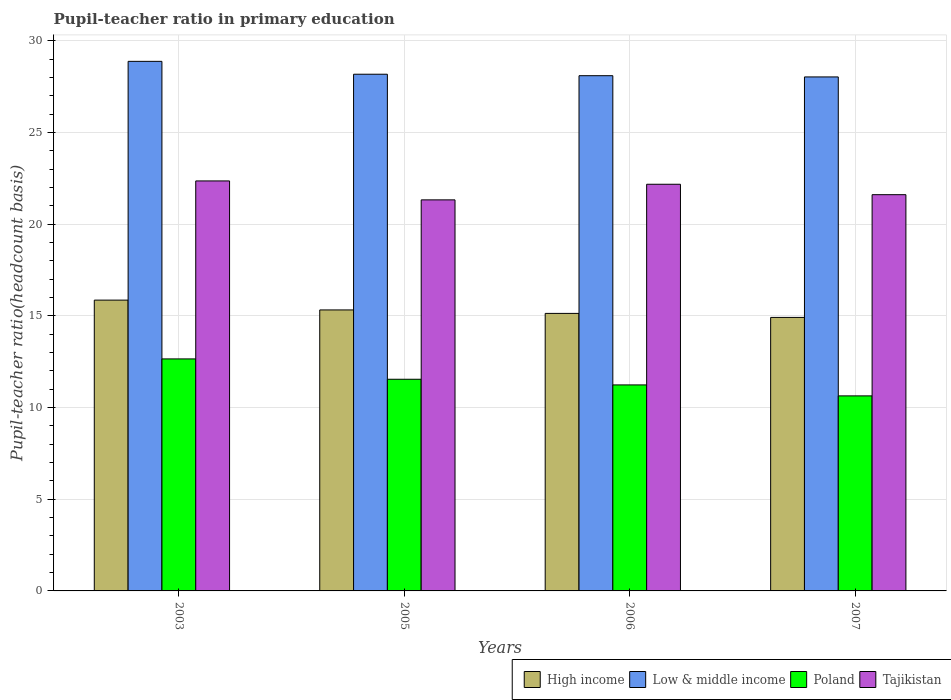Are the number of bars per tick equal to the number of legend labels?
Provide a short and direct response. Yes. How many bars are there on the 3rd tick from the right?
Offer a very short reply. 4. In how many cases, is the number of bars for a given year not equal to the number of legend labels?
Provide a short and direct response. 0. What is the pupil-teacher ratio in primary education in Poland in 2003?
Give a very brief answer. 12.65. Across all years, what is the maximum pupil-teacher ratio in primary education in High income?
Provide a succinct answer. 15.86. Across all years, what is the minimum pupil-teacher ratio in primary education in High income?
Provide a short and direct response. 14.92. In which year was the pupil-teacher ratio in primary education in Low & middle income maximum?
Your answer should be compact. 2003. What is the total pupil-teacher ratio in primary education in Tajikistan in the graph?
Make the answer very short. 87.47. What is the difference between the pupil-teacher ratio in primary education in Poland in 2003 and that in 2006?
Offer a terse response. 1.42. What is the difference between the pupil-teacher ratio in primary education in Low & middle income in 2003 and the pupil-teacher ratio in primary education in Poland in 2005?
Your answer should be very brief. 17.34. What is the average pupil-teacher ratio in primary education in Poland per year?
Your answer should be compact. 11.52. In the year 2007, what is the difference between the pupil-teacher ratio in primary education in High income and pupil-teacher ratio in primary education in Poland?
Your answer should be compact. 4.28. In how many years, is the pupil-teacher ratio in primary education in High income greater than 3?
Offer a terse response. 4. What is the ratio of the pupil-teacher ratio in primary education in Tajikistan in 2005 to that in 2007?
Give a very brief answer. 0.99. Is the pupil-teacher ratio in primary education in Low & middle income in 2003 less than that in 2005?
Provide a succinct answer. No. What is the difference between the highest and the second highest pupil-teacher ratio in primary education in Poland?
Provide a short and direct response. 1.11. What is the difference between the highest and the lowest pupil-teacher ratio in primary education in High income?
Offer a terse response. 0.94. Is the sum of the pupil-teacher ratio in primary education in Low & middle income in 2003 and 2005 greater than the maximum pupil-teacher ratio in primary education in High income across all years?
Offer a very short reply. Yes. What does the 2nd bar from the right in 2007 represents?
Give a very brief answer. Poland. Is it the case that in every year, the sum of the pupil-teacher ratio in primary education in Tajikistan and pupil-teacher ratio in primary education in Poland is greater than the pupil-teacher ratio in primary education in Low & middle income?
Your answer should be compact. Yes. How many bars are there?
Your answer should be compact. 16. How many years are there in the graph?
Give a very brief answer. 4. What is the difference between two consecutive major ticks on the Y-axis?
Provide a short and direct response. 5. Are the values on the major ticks of Y-axis written in scientific E-notation?
Offer a very short reply. No. Does the graph contain grids?
Your answer should be very brief. Yes. How many legend labels are there?
Keep it short and to the point. 4. How are the legend labels stacked?
Your answer should be very brief. Horizontal. What is the title of the graph?
Your answer should be compact. Pupil-teacher ratio in primary education. What is the label or title of the Y-axis?
Your response must be concise. Pupil-teacher ratio(headcount basis). What is the Pupil-teacher ratio(headcount basis) of High income in 2003?
Offer a very short reply. 15.86. What is the Pupil-teacher ratio(headcount basis) of Low & middle income in 2003?
Offer a very short reply. 28.88. What is the Pupil-teacher ratio(headcount basis) in Poland in 2003?
Provide a succinct answer. 12.65. What is the Pupil-teacher ratio(headcount basis) of Tajikistan in 2003?
Keep it short and to the point. 22.36. What is the Pupil-teacher ratio(headcount basis) in High income in 2005?
Keep it short and to the point. 15.32. What is the Pupil-teacher ratio(headcount basis) of Low & middle income in 2005?
Give a very brief answer. 28.18. What is the Pupil-teacher ratio(headcount basis) in Poland in 2005?
Make the answer very short. 11.54. What is the Pupil-teacher ratio(headcount basis) in Tajikistan in 2005?
Make the answer very short. 21.33. What is the Pupil-teacher ratio(headcount basis) of High income in 2006?
Make the answer very short. 15.14. What is the Pupil-teacher ratio(headcount basis) of Low & middle income in 2006?
Offer a terse response. 28.1. What is the Pupil-teacher ratio(headcount basis) in Poland in 2006?
Make the answer very short. 11.23. What is the Pupil-teacher ratio(headcount basis) of Tajikistan in 2006?
Provide a short and direct response. 22.18. What is the Pupil-teacher ratio(headcount basis) of High income in 2007?
Make the answer very short. 14.92. What is the Pupil-teacher ratio(headcount basis) in Low & middle income in 2007?
Keep it short and to the point. 28.03. What is the Pupil-teacher ratio(headcount basis) of Poland in 2007?
Offer a terse response. 10.64. What is the Pupil-teacher ratio(headcount basis) of Tajikistan in 2007?
Ensure brevity in your answer.  21.61. Across all years, what is the maximum Pupil-teacher ratio(headcount basis) in High income?
Give a very brief answer. 15.86. Across all years, what is the maximum Pupil-teacher ratio(headcount basis) of Low & middle income?
Give a very brief answer. 28.88. Across all years, what is the maximum Pupil-teacher ratio(headcount basis) in Poland?
Your answer should be compact. 12.65. Across all years, what is the maximum Pupil-teacher ratio(headcount basis) in Tajikistan?
Provide a short and direct response. 22.36. Across all years, what is the minimum Pupil-teacher ratio(headcount basis) in High income?
Provide a succinct answer. 14.92. Across all years, what is the minimum Pupil-teacher ratio(headcount basis) of Low & middle income?
Your answer should be compact. 28.03. Across all years, what is the minimum Pupil-teacher ratio(headcount basis) of Poland?
Offer a very short reply. 10.64. Across all years, what is the minimum Pupil-teacher ratio(headcount basis) in Tajikistan?
Make the answer very short. 21.33. What is the total Pupil-teacher ratio(headcount basis) of High income in the graph?
Your response must be concise. 61.23. What is the total Pupil-teacher ratio(headcount basis) of Low & middle income in the graph?
Keep it short and to the point. 113.19. What is the total Pupil-teacher ratio(headcount basis) in Poland in the graph?
Your answer should be compact. 46.07. What is the total Pupil-teacher ratio(headcount basis) in Tajikistan in the graph?
Give a very brief answer. 87.47. What is the difference between the Pupil-teacher ratio(headcount basis) of High income in 2003 and that in 2005?
Offer a very short reply. 0.54. What is the difference between the Pupil-teacher ratio(headcount basis) of Low & middle income in 2003 and that in 2005?
Make the answer very short. 0.7. What is the difference between the Pupil-teacher ratio(headcount basis) in Poland in 2003 and that in 2005?
Keep it short and to the point. 1.11. What is the difference between the Pupil-teacher ratio(headcount basis) of Tajikistan in 2003 and that in 2005?
Make the answer very short. 1.03. What is the difference between the Pupil-teacher ratio(headcount basis) in High income in 2003 and that in 2006?
Your answer should be very brief. 0.72. What is the difference between the Pupil-teacher ratio(headcount basis) of Low & middle income in 2003 and that in 2006?
Offer a terse response. 0.78. What is the difference between the Pupil-teacher ratio(headcount basis) in Poland in 2003 and that in 2006?
Your response must be concise. 1.42. What is the difference between the Pupil-teacher ratio(headcount basis) of Tajikistan in 2003 and that in 2006?
Offer a terse response. 0.18. What is the difference between the Pupil-teacher ratio(headcount basis) in High income in 2003 and that in 2007?
Ensure brevity in your answer.  0.94. What is the difference between the Pupil-teacher ratio(headcount basis) in Low & middle income in 2003 and that in 2007?
Keep it short and to the point. 0.85. What is the difference between the Pupil-teacher ratio(headcount basis) of Poland in 2003 and that in 2007?
Your answer should be very brief. 2.02. What is the difference between the Pupil-teacher ratio(headcount basis) of Tajikistan in 2003 and that in 2007?
Your answer should be compact. 0.75. What is the difference between the Pupil-teacher ratio(headcount basis) in High income in 2005 and that in 2006?
Your answer should be compact. 0.19. What is the difference between the Pupil-teacher ratio(headcount basis) in Low & middle income in 2005 and that in 2006?
Your answer should be compact. 0.08. What is the difference between the Pupil-teacher ratio(headcount basis) of Poland in 2005 and that in 2006?
Your answer should be compact. 0.31. What is the difference between the Pupil-teacher ratio(headcount basis) in Tajikistan in 2005 and that in 2006?
Offer a terse response. -0.85. What is the difference between the Pupil-teacher ratio(headcount basis) of High income in 2005 and that in 2007?
Give a very brief answer. 0.41. What is the difference between the Pupil-teacher ratio(headcount basis) in Low & middle income in 2005 and that in 2007?
Offer a terse response. 0.15. What is the difference between the Pupil-teacher ratio(headcount basis) in Poland in 2005 and that in 2007?
Give a very brief answer. 0.91. What is the difference between the Pupil-teacher ratio(headcount basis) in Tajikistan in 2005 and that in 2007?
Your answer should be very brief. -0.28. What is the difference between the Pupil-teacher ratio(headcount basis) of High income in 2006 and that in 2007?
Your answer should be very brief. 0.22. What is the difference between the Pupil-teacher ratio(headcount basis) in Low & middle income in 2006 and that in 2007?
Your answer should be very brief. 0.07. What is the difference between the Pupil-teacher ratio(headcount basis) of Poland in 2006 and that in 2007?
Your response must be concise. 0.6. What is the difference between the Pupil-teacher ratio(headcount basis) in Tajikistan in 2006 and that in 2007?
Give a very brief answer. 0.57. What is the difference between the Pupil-teacher ratio(headcount basis) of High income in 2003 and the Pupil-teacher ratio(headcount basis) of Low & middle income in 2005?
Provide a short and direct response. -12.32. What is the difference between the Pupil-teacher ratio(headcount basis) of High income in 2003 and the Pupil-teacher ratio(headcount basis) of Poland in 2005?
Make the answer very short. 4.32. What is the difference between the Pupil-teacher ratio(headcount basis) in High income in 2003 and the Pupil-teacher ratio(headcount basis) in Tajikistan in 2005?
Make the answer very short. -5.47. What is the difference between the Pupil-teacher ratio(headcount basis) in Low & middle income in 2003 and the Pupil-teacher ratio(headcount basis) in Poland in 2005?
Offer a very short reply. 17.34. What is the difference between the Pupil-teacher ratio(headcount basis) of Low & middle income in 2003 and the Pupil-teacher ratio(headcount basis) of Tajikistan in 2005?
Your answer should be compact. 7.55. What is the difference between the Pupil-teacher ratio(headcount basis) of Poland in 2003 and the Pupil-teacher ratio(headcount basis) of Tajikistan in 2005?
Give a very brief answer. -8.67. What is the difference between the Pupil-teacher ratio(headcount basis) of High income in 2003 and the Pupil-teacher ratio(headcount basis) of Low & middle income in 2006?
Provide a short and direct response. -12.24. What is the difference between the Pupil-teacher ratio(headcount basis) of High income in 2003 and the Pupil-teacher ratio(headcount basis) of Poland in 2006?
Your answer should be very brief. 4.62. What is the difference between the Pupil-teacher ratio(headcount basis) of High income in 2003 and the Pupil-teacher ratio(headcount basis) of Tajikistan in 2006?
Offer a very short reply. -6.32. What is the difference between the Pupil-teacher ratio(headcount basis) in Low & middle income in 2003 and the Pupil-teacher ratio(headcount basis) in Poland in 2006?
Keep it short and to the point. 17.65. What is the difference between the Pupil-teacher ratio(headcount basis) of Low & middle income in 2003 and the Pupil-teacher ratio(headcount basis) of Tajikistan in 2006?
Your answer should be very brief. 6.7. What is the difference between the Pupil-teacher ratio(headcount basis) in Poland in 2003 and the Pupil-teacher ratio(headcount basis) in Tajikistan in 2006?
Your answer should be very brief. -9.53. What is the difference between the Pupil-teacher ratio(headcount basis) of High income in 2003 and the Pupil-teacher ratio(headcount basis) of Low & middle income in 2007?
Make the answer very short. -12.17. What is the difference between the Pupil-teacher ratio(headcount basis) in High income in 2003 and the Pupil-teacher ratio(headcount basis) in Poland in 2007?
Provide a succinct answer. 5.22. What is the difference between the Pupil-teacher ratio(headcount basis) of High income in 2003 and the Pupil-teacher ratio(headcount basis) of Tajikistan in 2007?
Give a very brief answer. -5.75. What is the difference between the Pupil-teacher ratio(headcount basis) of Low & middle income in 2003 and the Pupil-teacher ratio(headcount basis) of Poland in 2007?
Give a very brief answer. 18.24. What is the difference between the Pupil-teacher ratio(headcount basis) of Low & middle income in 2003 and the Pupil-teacher ratio(headcount basis) of Tajikistan in 2007?
Provide a short and direct response. 7.27. What is the difference between the Pupil-teacher ratio(headcount basis) of Poland in 2003 and the Pupil-teacher ratio(headcount basis) of Tajikistan in 2007?
Ensure brevity in your answer.  -8.96. What is the difference between the Pupil-teacher ratio(headcount basis) in High income in 2005 and the Pupil-teacher ratio(headcount basis) in Low & middle income in 2006?
Offer a terse response. -12.77. What is the difference between the Pupil-teacher ratio(headcount basis) of High income in 2005 and the Pupil-teacher ratio(headcount basis) of Poland in 2006?
Offer a very short reply. 4.09. What is the difference between the Pupil-teacher ratio(headcount basis) of High income in 2005 and the Pupil-teacher ratio(headcount basis) of Tajikistan in 2006?
Give a very brief answer. -6.85. What is the difference between the Pupil-teacher ratio(headcount basis) of Low & middle income in 2005 and the Pupil-teacher ratio(headcount basis) of Poland in 2006?
Offer a terse response. 16.94. What is the difference between the Pupil-teacher ratio(headcount basis) in Low & middle income in 2005 and the Pupil-teacher ratio(headcount basis) in Tajikistan in 2006?
Ensure brevity in your answer.  6. What is the difference between the Pupil-teacher ratio(headcount basis) of Poland in 2005 and the Pupil-teacher ratio(headcount basis) of Tajikistan in 2006?
Offer a very short reply. -10.63. What is the difference between the Pupil-teacher ratio(headcount basis) in High income in 2005 and the Pupil-teacher ratio(headcount basis) in Low & middle income in 2007?
Your answer should be compact. -12.71. What is the difference between the Pupil-teacher ratio(headcount basis) in High income in 2005 and the Pupil-teacher ratio(headcount basis) in Poland in 2007?
Offer a terse response. 4.69. What is the difference between the Pupil-teacher ratio(headcount basis) of High income in 2005 and the Pupil-teacher ratio(headcount basis) of Tajikistan in 2007?
Offer a very short reply. -6.29. What is the difference between the Pupil-teacher ratio(headcount basis) in Low & middle income in 2005 and the Pupil-teacher ratio(headcount basis) in Poland in 2007?
Provide a succinct answer. 17.54. What is the difference between the Pupil-teacher ratio(headcount basis) in Low & middle income in 2005 and the Pupil-teacher ratio(headcount basis) in Tajikistan in 2007?
Keep it short and to the point. 6.57. What is the difference between the Pupil-teacher ratio(headcount basis) in Poland in 2005 and the Pupil-teacher ratio(headcount basis) in Tajikistan in 2007?
Provide a short and direct response. -10.07. What is the difference between the Pupil-teacher ratio(headcount basis) of High income in 2006 and the Pupil-teacher ratio(headcount basis) of Low & middle income in 2007?
Your answer should be compact. -12.9. What is the difference between the Pupil-teacher ratio(headcount basis) in High income in 2006 and the Pupil-teacher ratio(headcount basis) in Poland in 2007?
Offer a very short reply. 4.5. What is the difference between the Pupil-teacher ratio(headcount basis) in High income in 2006 and the Pupil-teacher ratio(headcount basis) in Tajikistan in 2007?
Keep it short and to the point. -6.47. What is the difference between the Pupil-teacher ratio(headcount basis) in Low & middle income in 2006 and the Pupil-teacher ratio(headcount basis) in Poland in 2007?
Keep it short and to the point. 17.46. What is the difference between the Pupil-teacher ratio(headcount basis) in Low & middle income in 2006 and the Pupil-teacher ratio(headcount basis) in Tajikistan in 2007?
Keep it short and to the point. 6.49. What is the difference between the Pupil-teacher ratio(headcount basis) of Poland in 2006 and the Pupil-teacher ratio(headcount basis) of Tajikistan in 2007?
Offer a very short reply. -10.37. What is the average Pupil-teacher ratio(headcount basis) in High income per year?
Offer a terse response. 15.31. What is the average Pupil-teacher ratio(headcount basis) in Low & middle income per year?
Ensure brevity in your answer.  28.3. What is the average Pupil-teacher ratio(headcount basis) in Poland per year?
Keep it short and to the point. 11.52. What is the average Pupil-teacher ratio(headcount basis) in Tajikistan per year?
Your answer should be very brief. 21.87. In the year 2003, what is the difference between the Pupil-teacher ratio(headcount basis) of High income and Pupil-teacher ratio(headcount basis) of Low & middle income?
Provide a short and direct response. -13.02. In the year 2003, what is the difference between the Pupil-teacher ratio(headcount basis) of High income and Pupil-teacher ratio(headcount basis) of Poland?
Your answer should be very brief. 3.21. In the year 2003, what is the difference between the Pupil-teacher ratio(headcount basis) of High income and Pupil-teacher ratio(headcount basis) of Tajikistan?
Keep it short and to the point. -6.5. In the year 2003, what is the difference between the Pupil-teacher ratio(headcount basis) of Low & middle income and Pupil-teacher ratio(headcount basis) of Poland?
Provide a short and direct response. 16.23. In the year 2003, what is the difference between the Pupil-teacher ratio(headcount basis) of Low & middle income and Pupil-teacher ratio(headcount basis) of Tajikistan?
Keep it short and to the point. 6.52. In the year 2003, what is the difference between the Pupil-teacher ratio(headcount basis) in Poland and Pupil-teacher ratio(headcount basis) in Tajikistan?
Offer a terse response. -9.71. In the year 2005, what is the difference between the Pupil-teacher ratio(headcount basis) of High income and Pupil-teacher ratio(headcount basis) of Low & middle income?
Keep it short and to the point. -12.85. In the year 2005, what is the difference between the Pupil-teacher ratio(headcount basis) in High income and Pupil-teacher ratio(headcount basis) in Poland?
Offer a terse response. 3.78. In the year 2005, what is the difference between the Pupil-teacher ratio(headcount basis) in High income and Pupil-teacher ratio(headcount basis) in Tajikistan?
Provide a short and direct response. -6. In the year 2005, what is the difference between the Pupil-teacher ratio(headcount basis) of Low & middle income and Pupil-teacher ratio(headcount basis) of Poland?
Your answer should be very brief. 16.64. In the year 2005, what is the difference between the Pupil-teacher ratio(headcount basis) of Low & middle income and Pupil-teacher ratio(headcount basis) of Tajikistan?
Provide a short and direct response. 6.85. In the year 2005, what is the difference between the Pupil-teacher ratio(headcount basis) of Poland and Pupil-teacher ratio(headcount basis) of Tajikistan?
Offer a very short reply. -9.78. In the year 2006, what is the difference between the Pupil-teacher ratio(headcount basis) of High income and Pupil-teacher ratio(headcount basis) of Low & middle income?
Offer a very short reply. -12.96. In the year 2006, what is the difference between the Pupil-teacher ratio(headcount basis) in High income and Pupil-teacher ratio(headcount basis) in Poland?
Give a very brief answer. 3.9. In the year 2006, what is the difference between the Pupil-teacher ratio(headcount basis) in High income and Pupil-teacher ratio(headcount basis) in Tajikistan?
Make the answer very short. -7.04. In the year 2006, what is the difference between the Pupil-teacher ratio(headcount basis) of Low & middle income and Pupil-teacher ratio(headcount basis) of Poland?
Offer a terse response. 16.86. In the year 2006, what is the difference between the Pupil-teacher ratio(headcount basis) in Low & middle income and Pupil-teacher ratio(headcount basis) in Tajikistan?
Provide a short and direct response. 5.92. In the year 2006, what is the difference between the Pupil-teacher ratio(headcount basis) in Poland and Pupil-teacher ratio(headcount basis) in Tajikistan?
Provide a short and direct response. -10.94. In the year 2007, what is the difference between the Pupil-teacher ratio(headcount basis) in High income and Pupil-teacher ratio(headcount basis) in Low & middle income?
Provide a succinct answer. -13.12. In the year 2007, what is the difference between the Pupil-teacher ratio(headcount basis) of High income and Pupil-teacher ratio(headcount basis) of Poland?
Offer a terse response. 4.28. In the year 2007, what is the difference between the Pupil-teacher ratio(headcount basis) of High income and Pupil-teacher ratio(headcount basis) of Tajikistan?
Give a very brief answer. -6.69. In the year 2007, what is the difference between the Pupil-teacher ratio(headcount basis) of Low & middle income and Pupil-teacher ratio(headcount basis) of Poland?
Provide a short and direct response. 17.39. In the year 2007, what is the difference between the Pupil-teacher ratio(headcount basis) of Low & middle income and Pupil-teacher ratio(headcount basis) of Tajikistan?
Provide a succinct answer. 6.42. In the year 2007, what is the difference between the Pupil-teacher ratio(headcount basis) in Poland and Pupil-teacher ratio(headcount basis) in Tajikistan?
Provide a succinct answer. -10.97. What is the ratio of the Pupil-teacher ratio(headcount basis) of High income in 2003 to that in 2005?
Your response must be concise. 1.03. What is the ratio of the Pupil-teacher ratio(headcount basis) of Low & middle income in 2003 to that in 2005?
Make the answer very short. 1.02. What is the ratio of the Pupil-teacher ratio(headcount basis) in Poland in 2003 to that in 2005?
Offer a terse response. 1.1. What is the ratio of the Pupil-teacher ratio(headcount basis) of Tajikistan in 2003 to that in 2005?
Give a very brief answer. 1.05. What is the ratio of the Pupil-teacher ratio(headcount basis) in High income in 2003 to that in 2006?
Provide a short and direct response. 1.05. What is the ratio of the Pupil-teacher ratio(headcount basis) of Low & middle income in 2003 to that in 2006?
Give a very brief answer. 1.03. What is the ratio of the Pupil-teacher ratio(headcount basis) in Poland in 2003 to that in 2006?
Ensure brevity in your answer.  1.13. What is the ratio of the Pupil-teacher ratio(headcount basis) of Tajikistan in 2003 to that in 2006?
Your response must be concise. 1.01. What is the ratio of the Pupil-teacher ratio(headcount basis) of High income in 2003 to that in 2007?
Make the answer very short. 1.06. What is the ratio of the Pupil-teacher ratio(headcount basis) of Low & middle income in 2003 to that in 2007?
Offer a very short reply. 1.03. What is the ratio of the Pupil-teacher ratio(headcount basis) in Poland in 2003 to that in 2007?
Keep it short and to the point. 1.19. What is the ratio of the Pupil-teacher ratio(headcount basis) in Tajikistan in 2003 to that in 2007?
Your answer should be very brief. 1.03. What is the ratio of the Pupil-teacher ratio(headcount basis) of High income in 2005 to that in 2006?
Ensure brevity in your answer.  1.01. What is the ratio of the Pupil-teacher ratio(headcount basis) of Low & middle income in 2005 to that in 2006?
Offer a very short reply. 1. What is the ratio of the Pupil-teacher ratio(headcount basis) in Poland in 2005 to that in 2006?
Offer a very short reply. 1.03. What is the ratio of the Pupil-teacher ratio(headcount basis) of Tajikistan in 2005 to that in 2006?
Offer a very short reply. 0.96. What is the ratio of the Pupil-teacher ratio(headcount basis) in High income in 2005 to that in 2007?
Provide a short and direct response. 1.03. What is the ratio of the Pupil-teacher ratio(headcount basis) in Low & middle income in 2005 to that in 2007?
Your answer should be compact. 1.01. What is the ratio of the Pupil-teacher ratio(headcount basis) in Poland in 2005 to that in 2007?
Make the answer very short. 1.09. What is the ratio of the Pupil-teacher ratio(headcount basis) of Tajikistan in 2005 to that in 2007?
Ensure brevity in your answer.  0.99. What is the ratio of the Pupil-teacher ratio(headcount basis) in High income in 2006 to that in 2007?
Offer a very short reply. 1.01. What is the ratio of the Pupil-teacher ratio(headcount basis) in Poland in 2006 to that in 2007?
Make the answer very short. 1.06. What is the ratio of the Pupil-teacher ratio(headcount basis) in Tajikistan in 2006 to that in 2007?
Give a very brief answer. 1.03. What is the difference between the highest and the second highest Pupil-teacher ratio(headcount basis) in High income?
Give a very brief answer. 0.54. What is the difference between the highest and the second highest Pupil-teacher ratio(headcount basis) of Low & middle income?
Provide a short and direct response. 0.7. What is the difference between the highest and the second highest Pupil-teacher ratio(headcount basis) of Poland?
Offer a terse response. 1.11. What is the difference between the highest and the second highest Pupil-teacher ratio(headcount basis) of Tajikistan?
Offer a terse response. 0.18. What is the difference between the highest and the lowest Pupil-teacher ratio(headcount basis) of High income?
Provide a short and direct response. 0.94. What is the difference between the highest and the lowest Pupil-teacher ratio(headcount basis) in Low & middle income?
Ensure brevity in your answer.  0.85. What is the difference between the highest and the lowest Pupil-teacher ratio(headcount basis) in Poland?
Give a very brief answer. 2.02. What is the difference between the highest and the lowest Pupil-teacher ratio(headcount basis) in Tajikistan?
Provide a succinct answer. 1.03. 